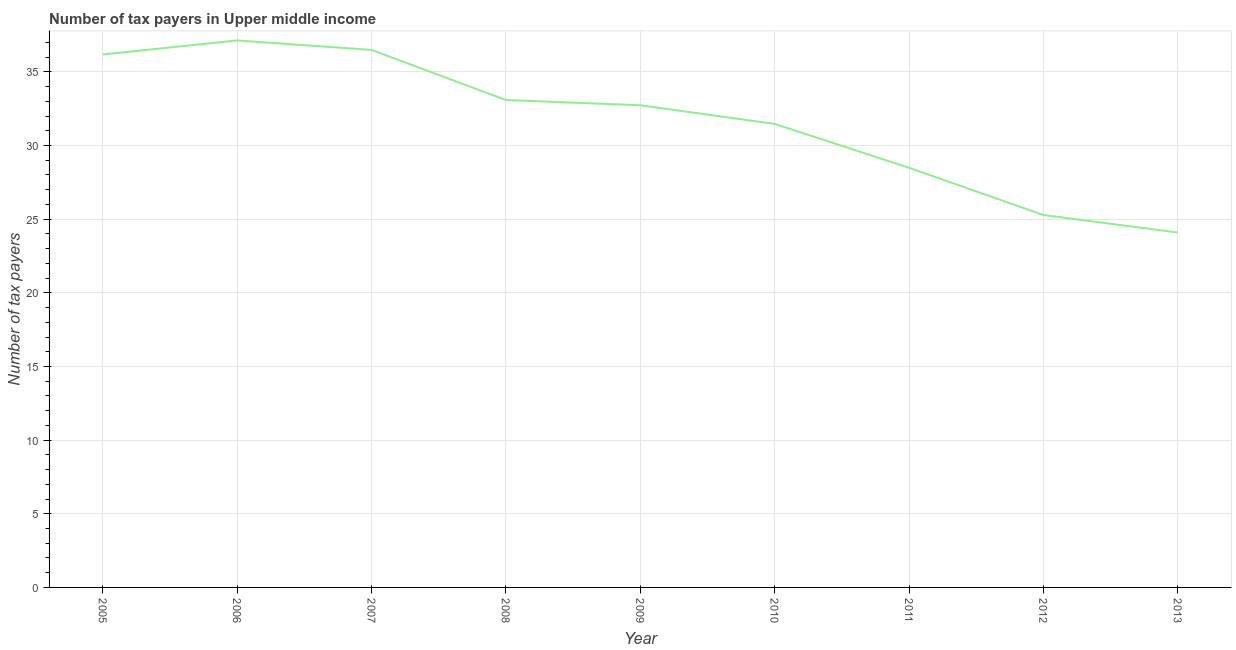What is the number of tax payers in 2008?
Your answer should be compact. 33.09. Across all years, what is the maximum number of tax payers?
Offer a terse response. 37.13. Across all years, what is the minimum number of tax payers?
Provide a short and direct response. 24.09. In which year was the number of tax payers minimum?
Provide a succinct answer. 2013. What is the sum of the number of tax payers?
Provide a short and direct response. 284.96. What is the difference between the number of tax payers in 2007 and 2009?
Ensure brevity in your answer.  3.76. What is the average number of tax payers per year?
Make the answer very short. 31.66. What is the median number of tax payers?
Provide a short and direct response. 32.73. Do a majority of the years between 2010 and 2007 (inclusive) have number of tax payers greater than 7 ?
Keep it short and to the point. Yes. What is the ratio of the number of tax payers in 2008 to that in 2012?
Ensure brevity in your answer.  1.31. What is the difference between the highest and the second highest number of tax payers?
Provide a succinct answer. 0.64. Is the sum of the number of tax payers in 2012 and 2013 greater than the maximum number of tax payers across all years?
Offer a terse response. Yes. What is the difference between the highest and the lowest number of tax payers?
Provide a short and direct response. 13.04. In how many years, is the number of tax payers greater than the average number of tax payers taken over all years?
Your response must be concise. 5. Does the number of tax payers monotonically increase over the years?
Offer a terse response. No. How many lines are there?
Provide a succinct answer. 1. How many years are there in the graph?
Provide a short and direct response. 9. Are the values on the major ticks of Y-axis written in scientific E-notation?
Your answer should be compact. No. Does the graph contain any zero values?
Offer a terse response. No. What is the title of the graph?
Provide a succinct answer. Number of tax payers in Upper middle income. What is the label or title of the X-axis?
Your answer should be compact. Year. What is the label or title of the Y-axis?
Your answer should be very brief. Number of tax payers. What is the Number of tax payers of 2005?
Your answer should be compact. 36.18. What is the Number of tax payers of 2006?
Keep it short and to the point. 37.13. What is the Number of tax payers of 2007?
Keep it short and to the point. 36.49. What is the Number of tax payers in 2008?
Provide a succinct answer. 33.09. What is the Number of tax payers of 2009?
Ensure brevity in your answer.  32.73. What is the Number of tax payers of 2010?
Your answer should be compact. 31.47. What is the Number of tax payers in 2011?
Make the answer very short. 28.49. What is the Number of tax payers of 2012?
Provide a succinct answer. 25.28. What is the Number of tax payers in 2013?
Offer a terse response. 24.09. What is the difference between the Number of tax payers in 2005 and 2006?
Give a very brief answer. -0.95. What is the difference between the Number of tax payers in 2005 and 2007?
Keep it short and to the point. -0.31. What is the difference between the Number of tax payers in 2005 and 2008?
Keep it short and to the point. 3.09. What is the difference between the Number of tax payers in 2005 and 2009?
Offer a terse response. 3.45. What is the difference between the Number of tax payers in 2005 and 2010?
Offer a very short reply. 4.72. What is the difference between the Number of tax payers in 2005 and 2011?
Your answer should be compact. 7.69. What is the difference between the Number of tax payers in 2005 and 2012?
Provide a succinct answer. 10.9. What is the difference between the Number of tax payers in 2005 and 2013?
Make the answer very short. 12.09. What is the difference between the Number of tax payers in 2006 and 2007?
Your answer should be compact. 0.64. What is the difference between the Number of tax payers in 2006 and 2008?
Make the answer very short. 4.04. What is the difference between the Number of tax payers in 2006 and 2010?
Your answer should be very brief. 5.67. What is the difference between the Number of tax payers in 2006 and 2011?
Your answer should be compact. 8.64. What is the difference between the Number of tax payers in 2006 and 2012?
Ensure brevity in your answer.  11.85. What is the difference between the Number of tax payers in 2006 and 2013?
Make the answer very short. 13.04. What is the difference between the Number of tax payers in 2007 and 2009?
Provide a succinct answer. 3.76. What is the difference between the Number of tax payers in 2007 and 2010?
Keep it short and to the point. 5.02. What is the difference between the Number of tax payers in 2007 and 2012?
Your response must be concise. 11.21. What is the difference between the Number of tax payers in 2007 and 2013?
Make the answer very short. 12.4. What is the difference between the Number of tax payers in 2008 and 2009?
Offer a terse response. 0.36. What is the difference between the Number of tax payers in 2008 and 2010?
Give a very brief answer. 1.62. What is the difference between the Number of tax payers in 2008 and 2012?
Provide a succinct answer. 7.81. What is the difference between the Number of tax payers in 2008 and 2013?
Provide a succinct answer. 9. What is the difference between the Number of tax payers in 2009 and 2010?
Make the answer very short. 1.27. What is the difference between the Number of tax payers in 2009 and 2011?
Offer a terse response. 4.24. What is the difference between the Number of tax payers in 2009 and 2012?
Offer a very short reply. 7.45. What is the difference between the Number of tax payers in 2009 and 2013?
Your answer should be compact. 8.64. What is the difference between the Number of tax payers in 2010 and 2011?
Offer a terse response. 2.98. What is the difference between the Number of tax payers in 2010 and 2012?
Offer a very short reply. 6.18. What is the difference between the Number of tax payers in 2010 and 2013?
Provide a succinct answer. 7.37. What is the difference between the Number of tax payers in 2011 and 2012?
Offer a terse response. 3.21. What is the difference between the Number of tax payers in 2011 and 2013?
Ensure brevity in your answer.  4.4. What is the difference between the Number of tax payers in 2012 and 2013?
Ensure brevity in your answer.  1.19. What is the ratio of the Number of tax payers in 2005 to that in 2008?
Keep it short and to the point. 1.09. What is the ratio of the Number of tax payers in 2005 to that in 2009?
Your response must be concise. 1.1. What is the ratio of the Number of tax payers in 2005 to that in 2010?
Your answer should be very brief. 1.15. What is the ratio of the Number of tax payers in 2005 to that in 2011?
Make the answer very short. 1.27. What is the ratio of the Number of tax payers in 2005 to that in 2012?
Provide a short and direct response. 1.43. What is the ratio of the Number of tax payers in 2005 to that in 2013?
Offer a very short reply. 1.5. What is the ratio of the Number of tax payers in 2006 to that in 2007?
Your response must be concise. 1.02. What is the ratio of the Number of tax payers in 2006 to that in 2008?
Your response must be concise. 1.12. What is the ratio of the Number of tax payers in 2006 to that in 2009?
Your response must be concise. 1.13. What is the ratio of the Number of tax payers in 2006 to that in 2010?
Ensure brevity in your answer.  1.18. What is the ratio of the Number of tax payers in 2006 to that in 2011?
Ensure brevity in your answer.  1.3. What is the ratio of the Number of tax payers in 2006 to that in 2012?
Offer a very short reply. 1.47. What is the ratio of the Number of tax payers in 2006 to that in 2013?
Keep it short and to the point. 1.54. What is the ratio of the Number of tax payers in 2007 to that in 2008?
Offer a terse response. 1.1. What is the ratio of the Number of tax payers in 2007 to that in 2009?
Provide a short and direct response. 1.11. What is the ratio of the Number of tax payers in 2007 to that in 2010?
Offer a terse response. 1.16. What is the ratio of the Number of tax payers in 2007 to that in 2011?
Ensure brevity in your answer.  1.28. What is the ratio of the Number of tax payers in 2007 to that in 2012?
Your response must be concise. 1.44. What is the ratio of the Number of tax payers in 2007 to that in 2013?
Provide a short and direct response. 1.51. What is the ratio of the Number of tax payers in 2008 to that in 2010?
Your response must be concise. 1.05. What is the ratio of the Number of tax payers in 2008 to that in 2011?
Your response must be concise. 1.16. What is the ratio of the Number of tax payers in 2008 to that in 2012?
Ensure brevity in your answer.  1.31. What is the ratio of the Number of tax payers in 2008 to that in 2013?
Your answer should be compact. 1.37. What is the ratio of the Number of tax payers in 2009 to that in 2010?
Provide a short and direct response. 1.04. What is the ratio of the Number of tax payers in 2009 to that in 2011?
Ensure brevity in your answer.  1.15. What is the ratio of the Number of tax payers in 2009 to that in 2012?
Provide a short and direct response. 1.29. What is the ratio of the Number of tax payers in 2009 to that in 2013?
Give a very brief answer. 1.36. What is the ratio of the Number of tax payers in 2010 to that in 2011?
Offer a terse response. 1.1. What is the ratio of the Number of tax payers in 2010 to that in 2012?
Your response must be concise. 1.25. What is the ratio of the Number of tax payers in 2010 to that in 2013?
Your answer should be compact. 1.31. What is the ratio of the Number of tax payers in 2011 to that in 2012?
Your answer should be very brief. 1.13. What is the ratio of the Number of tax payers in 2011 to that in 2013?
Make the answer very short. 1.18. What is the ratio of the Number of tax payers in 2012 to that in 2013?
Offer a very short reply. 1.05. 